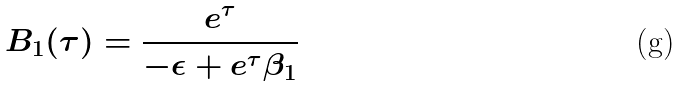<formula> <loc_0><loc_0><loc_500><loc_500>B _ { 1 } ( \tau ) = \frac { e ^ { \tau } } { - \epsilon + e ^ { \tau } \beta _ { 1 } }</formula> 